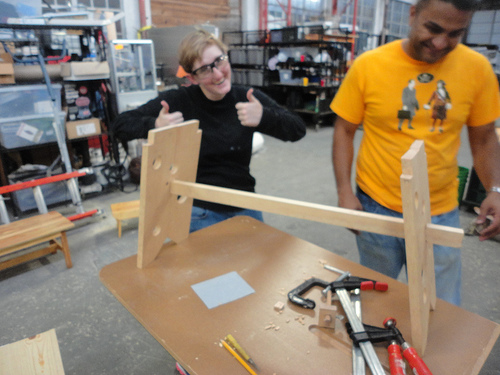<image>
Can you confirm if the board is on the table? Yes. Looking at the image, I can see the board is positioned on top of the table, with the table providing support. Is the man behind the table? Yes. From this viewpoint, the man is positioned behind the table, with the table partially or fully occluding the man. 